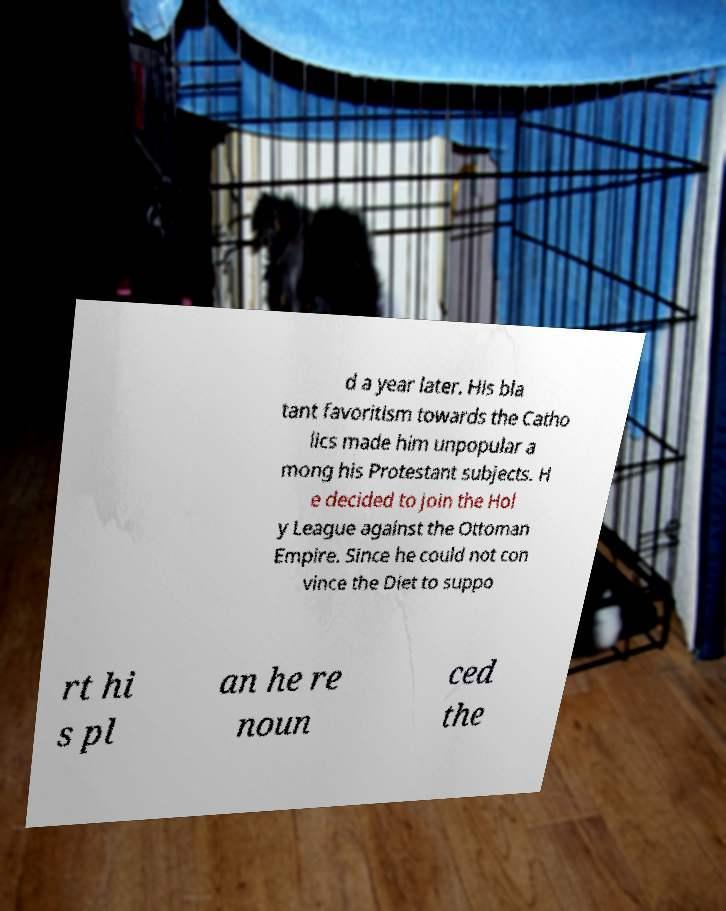Can you read and provide the text displayed in the image?This photo seems to have some interesting text. Can you extract and type it out for me? d a year later. His bla tant favoritism towards the Catho lics made him unpopular a mong his Protestant subjects. H e decided to join the Hol y League against the Ottoman Empire. Since he could not con vince the Diet to suppo rt hi s pl an he re noun ced the 